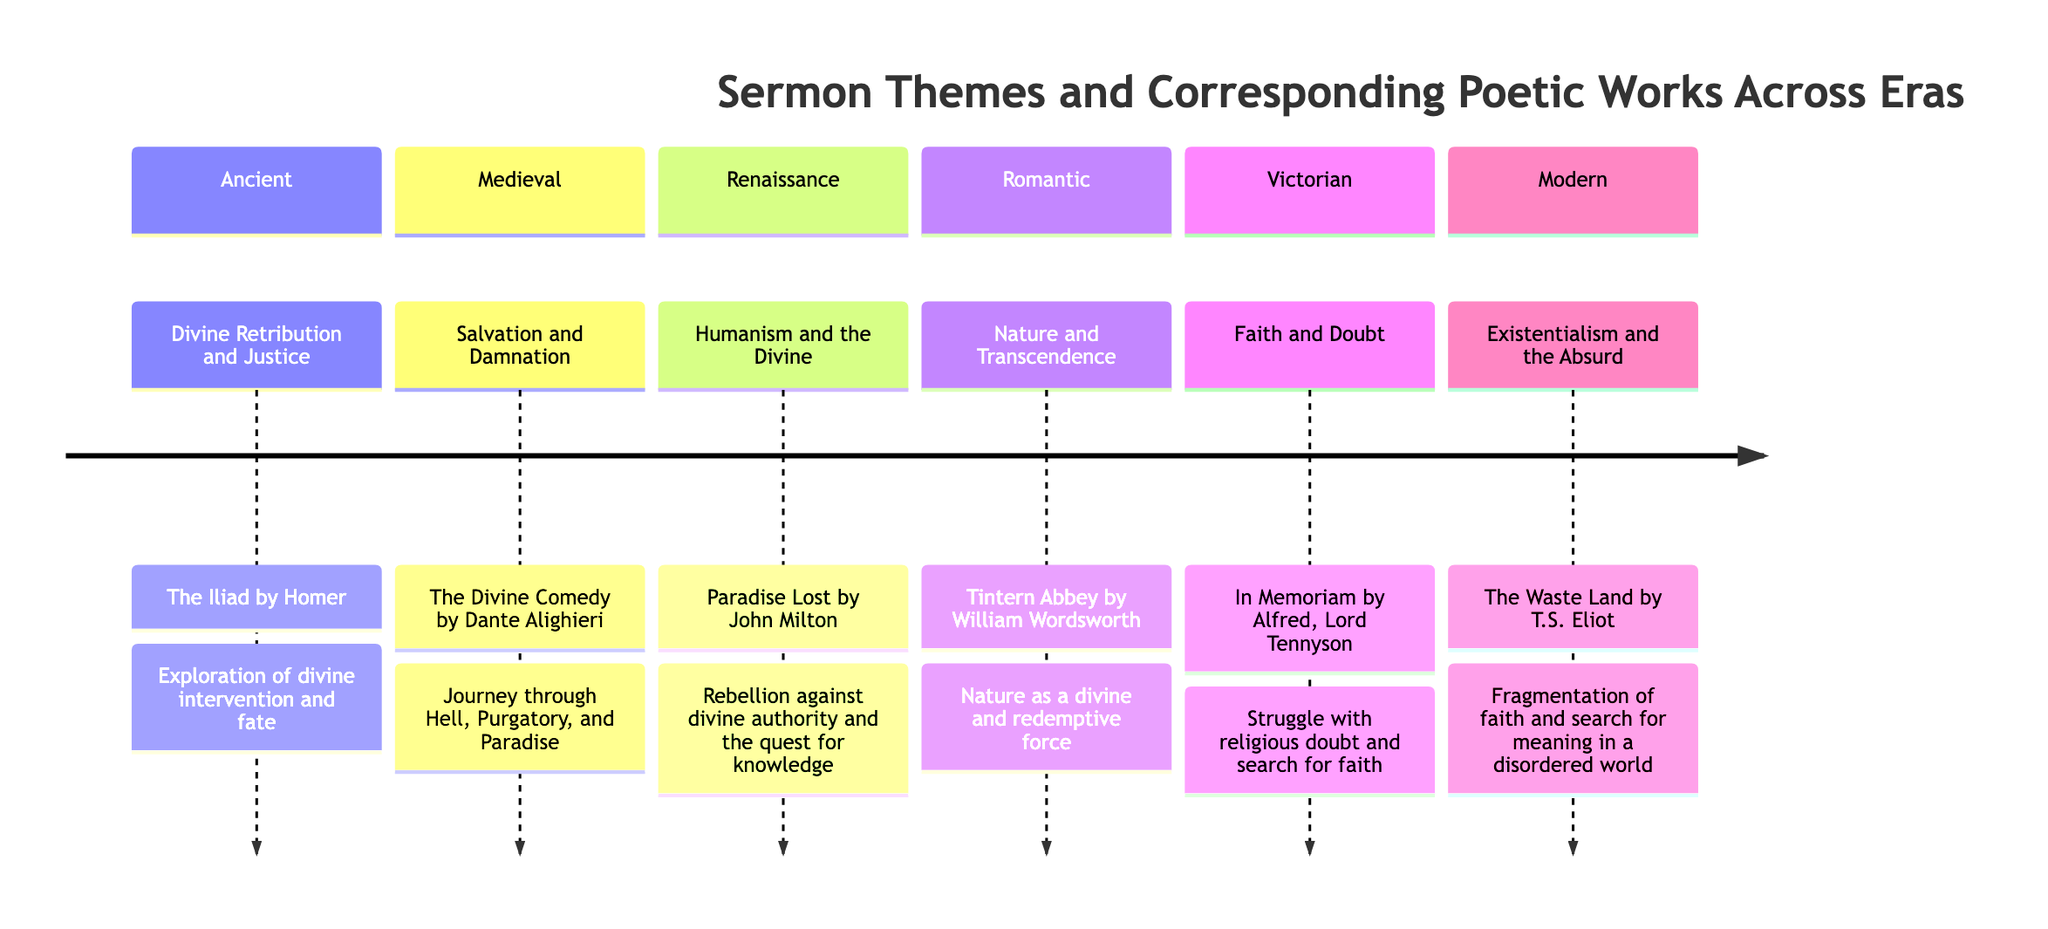What is the sermon theme from the Renaissance era? The diagram lists "Humanism and the Divine" as the sermon theme associated with the Renaissance era. This can be found easily in the section of the timeline designated for Renaissance.
Answer: Humanism and the Divine Which poetic work corresponds to the theme of Faith and Doubt? By referring to the Victorian section of the diagram, we see that "In Memoriam by Alfred, Lord Tennyson" corresponds to the theme of Faith and Doubt.
Answer: In Memoriam by Alfred, Lord Tennyson How many eras are represented in the timeline? The timeline shows six distinct sections, each representing a different era related to sermon themes and poetic works. By counting the sections, we arrive at a total of six.
Answer: 6 What linking idea is associated with The Waste Land? Looking at the Modern section, we find the linking idea associated with "The Waste Land by T.S. Eliot" is "Fragmentation of faith and search for meaning in a disordered world." This directly connects the poetic work to its existential themes.
Answer: Fragmentation of faith and search for meaning in a disordered world Which era features the sermon theme of Nature and Transcendence? By examining the timeline, we can see that the Romantic era discusses the theme of Nature and Transcendence. This information is explicitly stated in the section dedicated to this period.
Answer: Romantic What does the theme of Salvation and Damnation relate to in poetic works? The Medieval section reveals that the theme of "Salvation and Damnation" relates to "The Divine Comedy by Dante Alighieri," which is specified alongside the sermon theme in the diagram.
Answer: The Divine Comedy by Dante Alighieri How does the sermon theme in the Ancient era compare with that of the Modern era? The Ancient era features the theme of "Divine Retribution and Justice," while the Modern era presents "Existentialism and the Absurd." Comparing both shows a transition from divine justice to existential questioning in human experience.
Answer: Transition from divine justice to existential questioning What is the overall common linking idea across the timeline? Each linking idea ties back to the themes explored in both sermons and poetry, reflecting a spiritual and existential exploration through the ages, emphasizing the search for meaning, knowledge, and faith amidst challenges.
Answer: Spiritual and existential exploration 